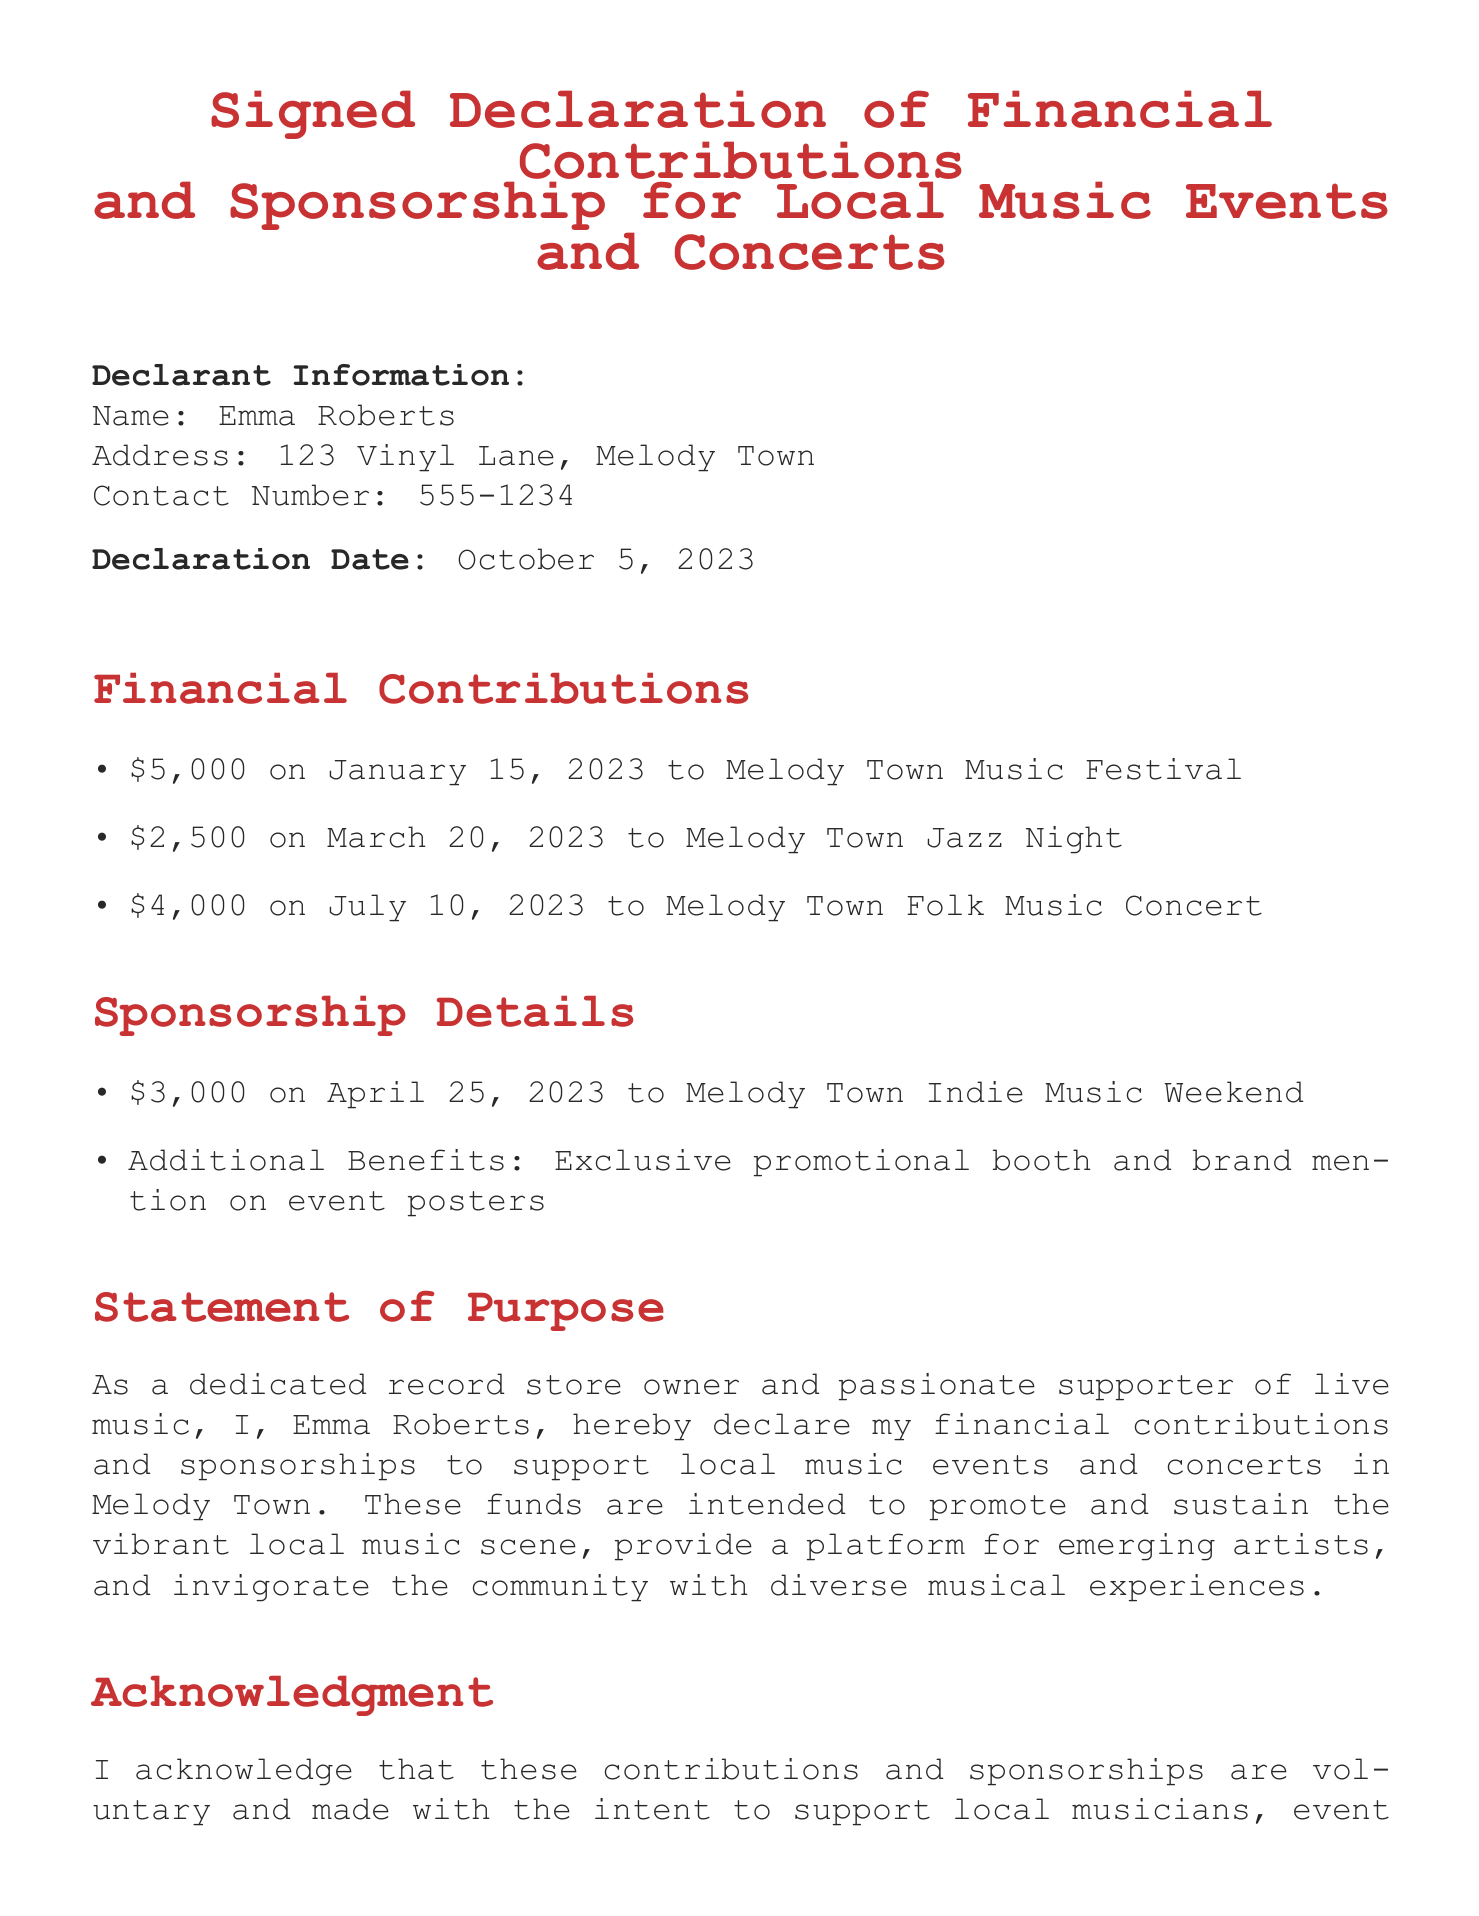What is the name of the declarant? The declarant's name is found at the top of the document under Declarant Information.
Answer: Emma Roberts What is the address of the declarant? The address is specified right below the name in the Declarant Information section.
Answer: 123 Vinyl Lane, Melody Town How much was contributed to the Melody Town Music Festival? This amount is listed in the Financial Contributions section, reflecting a specific donation.
Answer: $5,000 What date was the declaration made? The date of the declaration is stated clearly in the document, following the Declarant Information.
Answer: October 5, 2023 How much was spent on sponsorship for the Melody Town Indie Music Weekend? This amount is mentioned in the Sponsorship Details section, indicating how much was allocated.
Answer: $3,000 What is the purpose of the financial contributions? The purpose can be inferred from the Statement of Purpose which outlines the intent of the contributions.
Answer: Support local music events What benefits are included with the sponsorship? This detail is provided in the Sponsorship Details section, which lists the additional perks.
Answer: Exclusive promotional booth and brand mention on event posters How many financial contributions are listed in the document? This number can be counted from the items listed in the Financial Contributions section.
Answer: Three Who acknowledges the contributions as voluntary? The acknowledgment comes from the declarant as stated in the Acknowledgment section.
Answer: Emma Roberts 